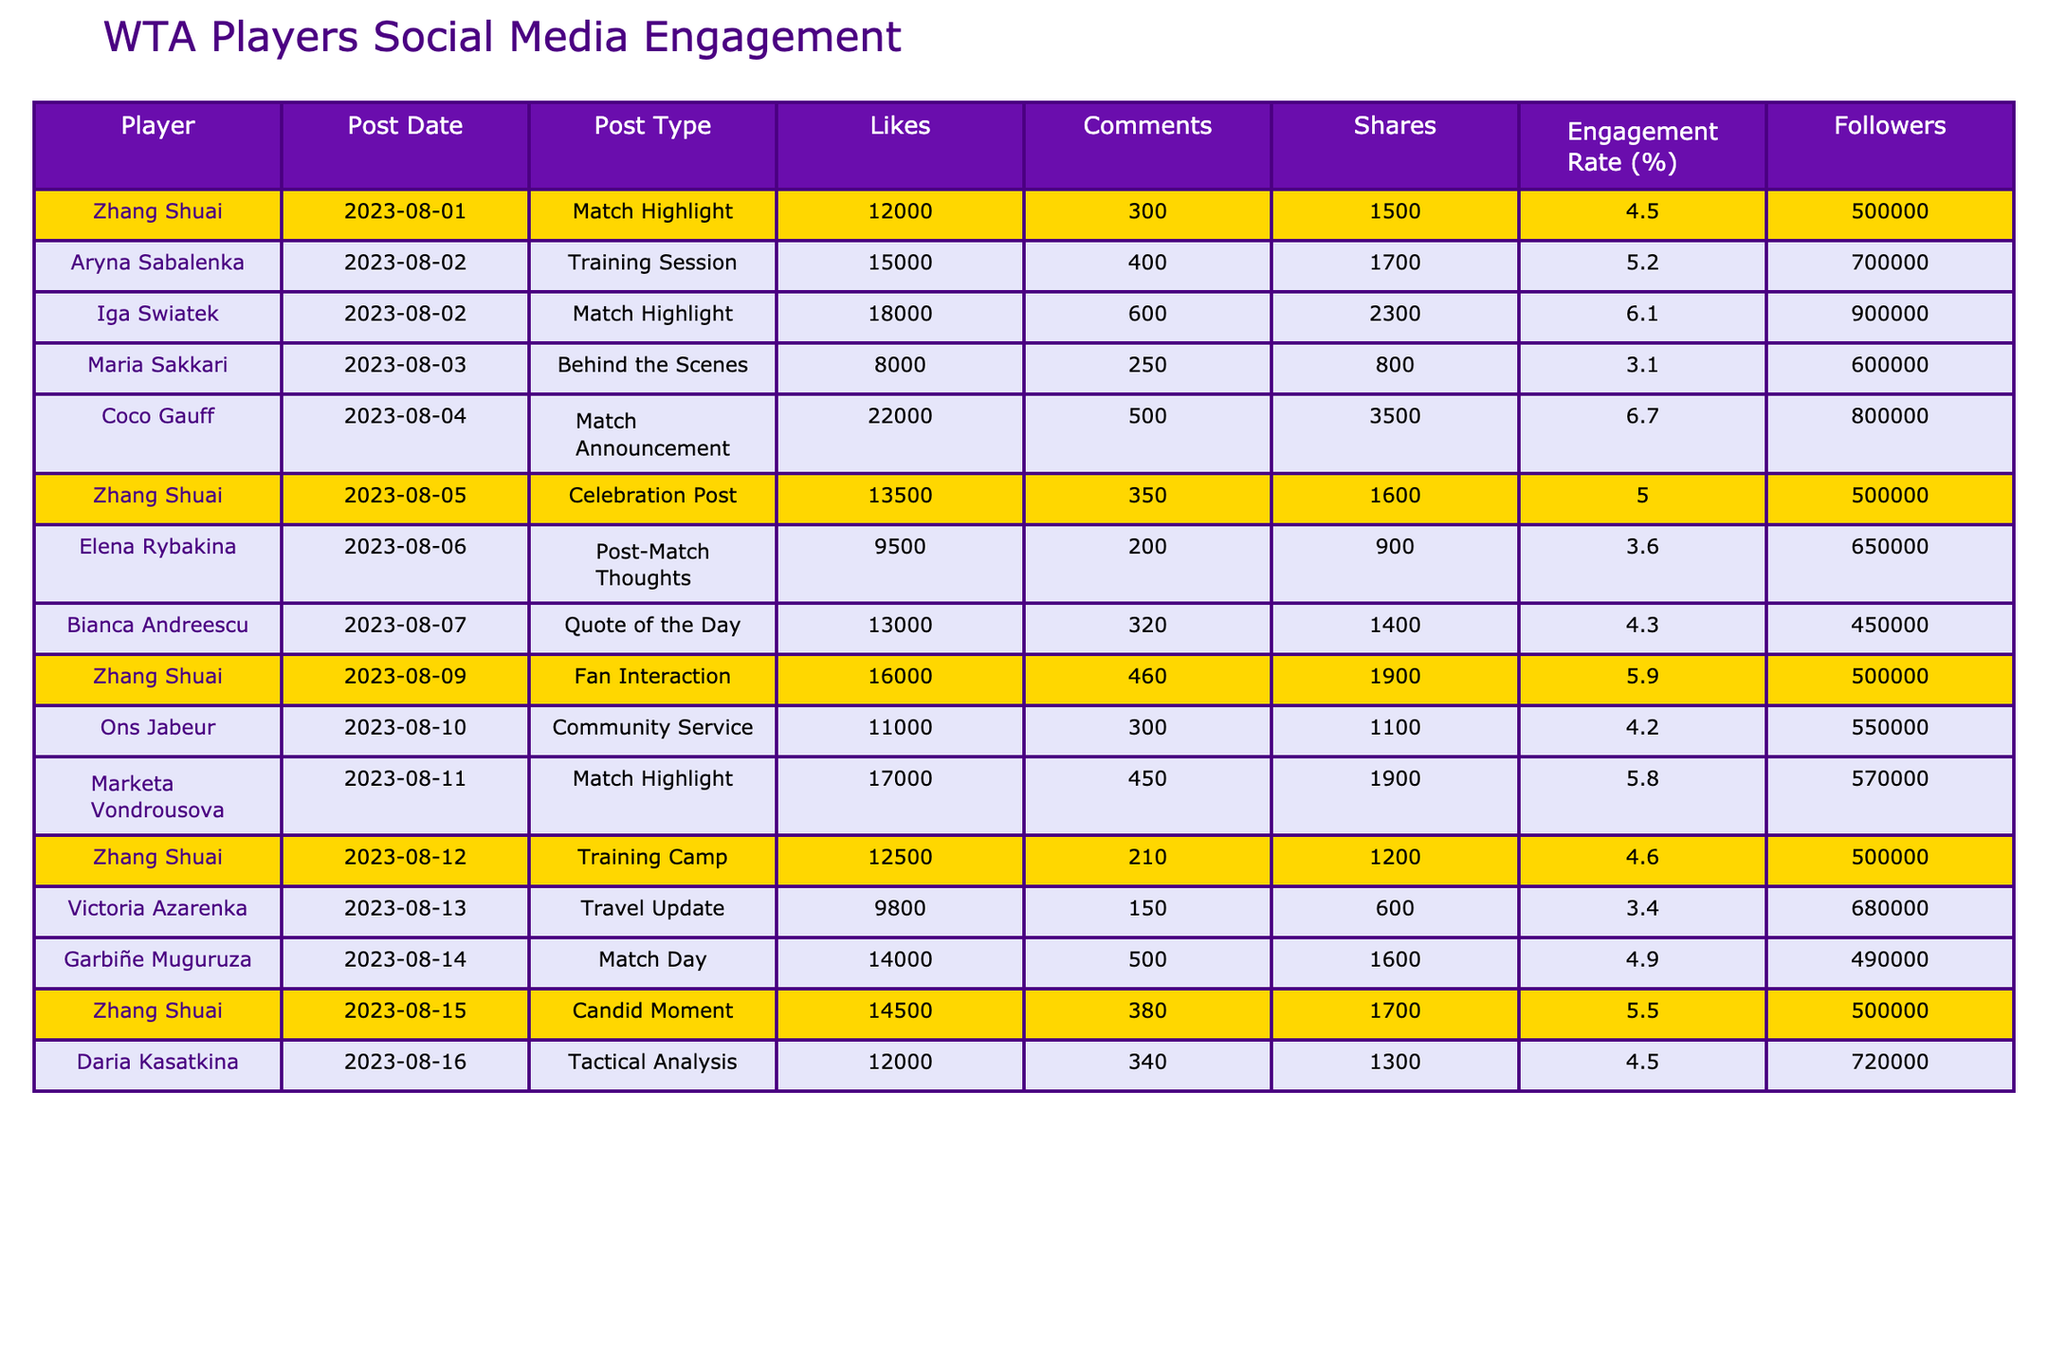What is the total number of likes on Zhang Shuai's posts? Zhang Shuai has three posts with likes of 12000, 13500, and 16000. Adding these values gives us 12000 + 13500 + 16000 = 41500.
Answer: 41500 Which WTA player had the highest engagement rate? The engagement rates for all players can be compared: Zhang Shuai - 4.5%, Aryna Sabalenka - 5.2%, Iga Swiatek - 6.1%, Coco Gauff - 6.7%, Maria Sakkari - 3.1%, and others. The highest is Coco Gauff with 6.7%.
Answer: Coco Gauff Did Zhang Shuai receive more likes on her celebration post than on her match highlight post? The likes on Zhang Shuai's celebration post are 13500, while her match highlight post received 12000. Since 13500 > 12000, she received more likes on the celebration post.
Answer: Yes What is the average engagement rate of Zhang Shuai's posts? Zhang Shuai has three posts with engagement rates of 4.5%, 5.0%, and 5.9%. The average is calculated as (4.5 + 5.0 + 5.9) / 3 = 5.13%.
Answer: 5.13% Which post type had the most total shares across all players? Totalling the shares for each player: Match Highlight - 1500, Training Session - 1700, Match Highlight - 2300, Behind the Scenes - 800, Match Announcement - 3500, and others. The maximum shares are from Coco Gauff's Match Announcement post with 3500 shares.
Answer: Match Announcement Is Iga Swiatek more popular than Zhang Shuai based on follower count? Iga Swiatek has 900000 followers, while Zhang Shuai has 500000 followers. Since 900000 > 500000, Iga Swiatek is more popular based on those numbers.
Answer: Yes What is the difference in total comments between Zhang Shuai's posts and Aryna Sabalenka's post? Zhang Shuai has received 300 + 350 + 460 = 1110 comments while Aryna Sabalenka received 400 comments. The difference is 1110 - 400 = 710.
Answer: 710 Which player had the most likes on a single post? Checking the likes for each player: Zhang Shuai (16000), Aryna Sabalenka (15000), Iga Swiatek (18000), Coco Gauff (22000), and others. The most likes are from Coco Gauff with 22000 likes.
Answer: Coco Gauff What is the combined total of shares on Zhang Shuai's posts? The shares for Zhang Shuai are 1500, 1600, and 1900. Summing them gives 1500 + 1600 + 1900 = 5000 shares in total.
Answer: 5000 Which two post types had the lowest engagement rates? Comparing engagement rates: Maria Sakkari's Behind the Scenes (3.1%) and Victoria Azarenka's Travel Update (3.4%) are the lowest.
Answer: Behind the Scenes and Travel Update 